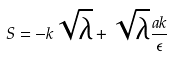<formula> <loc_0><loc_0><loc_500><loc_500>S = - k \sqrt { \lambda } + \sqrt { \lambda } \frac { a k } { \epsilon }</formula> 